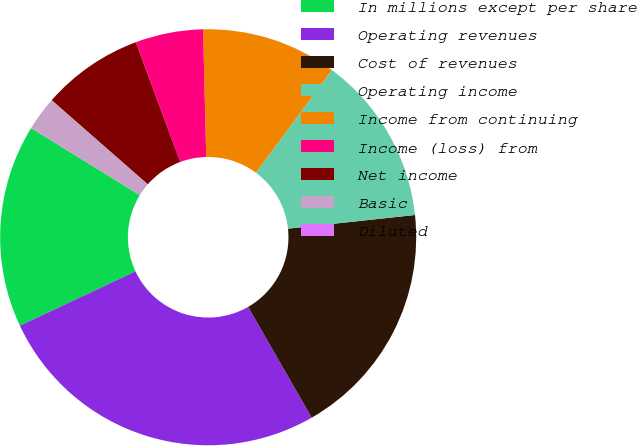Convert chart. <chart><loc_0><loc_0><loc_500><loc_500><pie_chart><fcel>In millions except per share<fcel>Operating revenues<fcel>Cost of revenues<fcel>Operating income<fcel>Income from continuing<fcel>Income (loss) from<fcel>Net income<fcel>Basic<fcel>Diluted<nl><fcel>15.79%<fcel>26.31%<fcel>18.42%<fcel>13.16%<fcel>10.53%<fcel>5.27%<fcel>7.9%<fcel>2.64%<fcel>0.01%<nl></chart> 